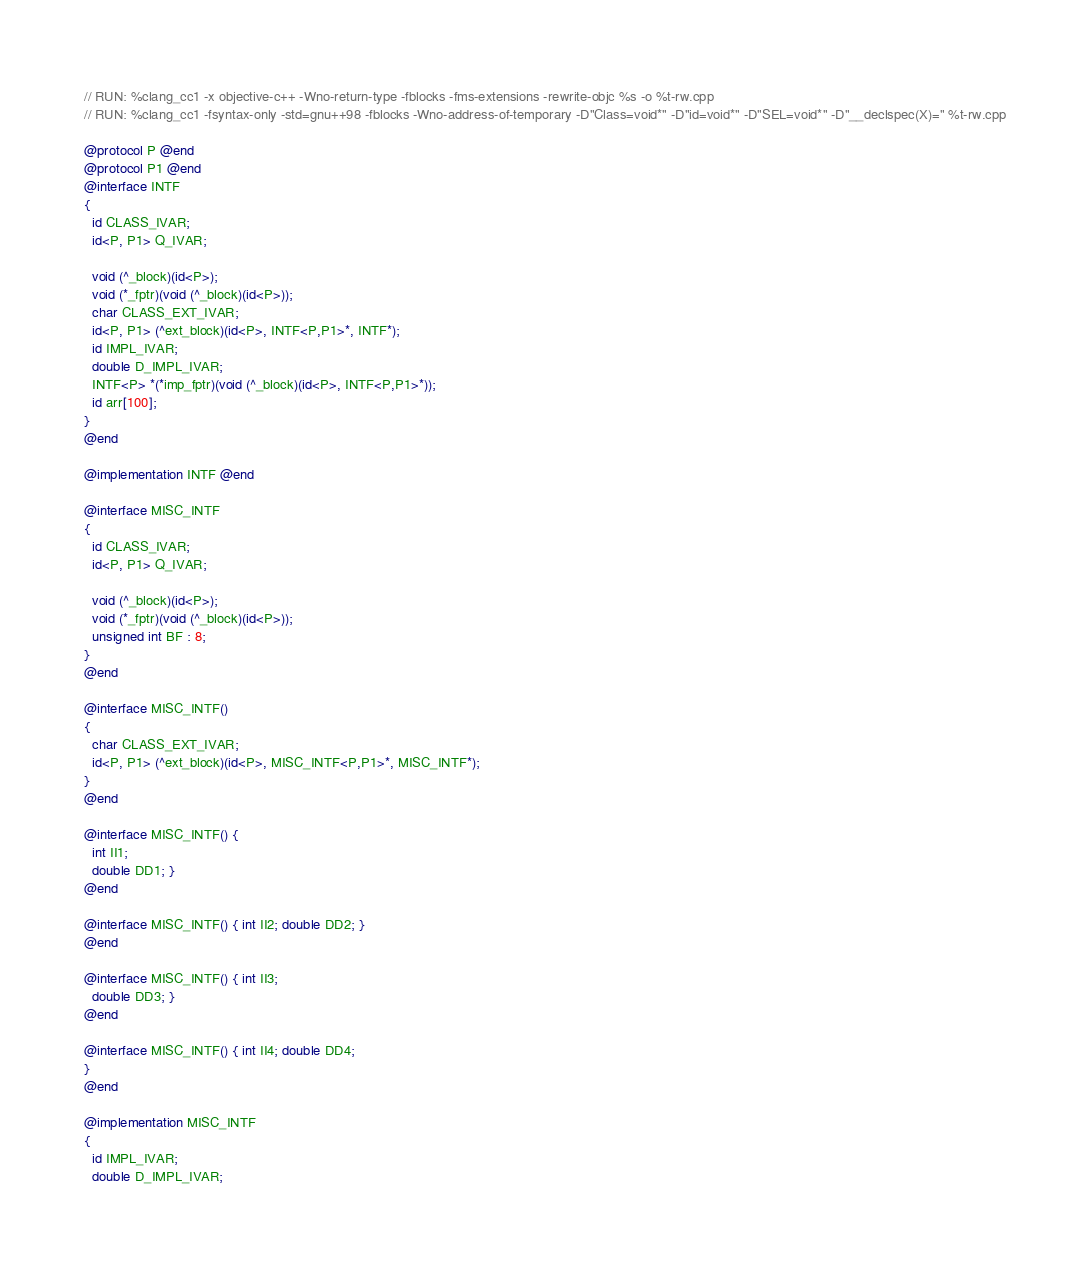<code> <loc_0><loc_0><loc_500><loc_500><_ObjectiveC_>// RUN: %clang_cc1 -x objective-c++ -Wno-return-type -fblocks -fms-extensions -rewrite-objc %s -o %t-rw.cpp
// RUN: %clang_cc1 -fsyntax-only -std=gnu++98 -fblocks -Wno-address-of-temporary -D"Class=void*" -D"id=void*" -D"SEL=void*" -D"__declspec(X)=" %t-rw.cpp

@protocol P @end
@protocol P1 @end
@interface INTF
{
  id CLASS_IVAR;
  id<P, P1> Q_IVAR;

  void (^_block)(id<P>);
  void (*_fptr)(void (^_block)(id<P>));
  char CLASS_EXT_IVAR;
  id<P, P1> (^ext_block)(id<P>, INTF<P,P1>*, INTF*);
  id IMPL_IVAR;
  double D_IMPL_IVAR;
  INTF<P> *(*imp_fptr)(void (^_block)(id<P>, INTF<P,P1>*));
  id arr[100];
}
@end

@implementation INTF @end

@interface MISC_INTF
{
  id CLASS_IVAR;
  id<P, P1> Q_IVAR;

  void (^_block)(id<P>);
  void (*_fptr)(void (^_block)(id<P>));
  unsigned int BF : 8;
}
@end

@interface MISC_INTF()
{
  char CLASS_EXT_IVAR;
  id<P, P1> (^ext_block)(id<P>, MISC_INTF<P,P1>*, MISC_INTF*);
}
@end

@interface MISC_INTF() {
  int II1;
  double DD1; }
@end

@interface MISC_INTF() { int II2; double DD2; }
@end

@interface MISC_INTF() { int II3; 
  double DD3; }
@end

@interface MISC_INTF() { int II4; double DD4; 
}
@end

@implementation MISC_INTF
{
  id IMPL_IVAR;
  double D_IMPL_IVAR;</code> 